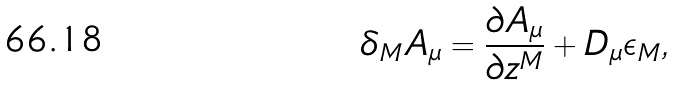<formula> <loc_0><loc_0><loc_500><loc_500>\delta _ { M } A _ { \mu } = \frac { \partial A _ { \mu } } { \partial z ^ { M } } + D _ { \mu } \epsilon _ { M } ,</formula> 